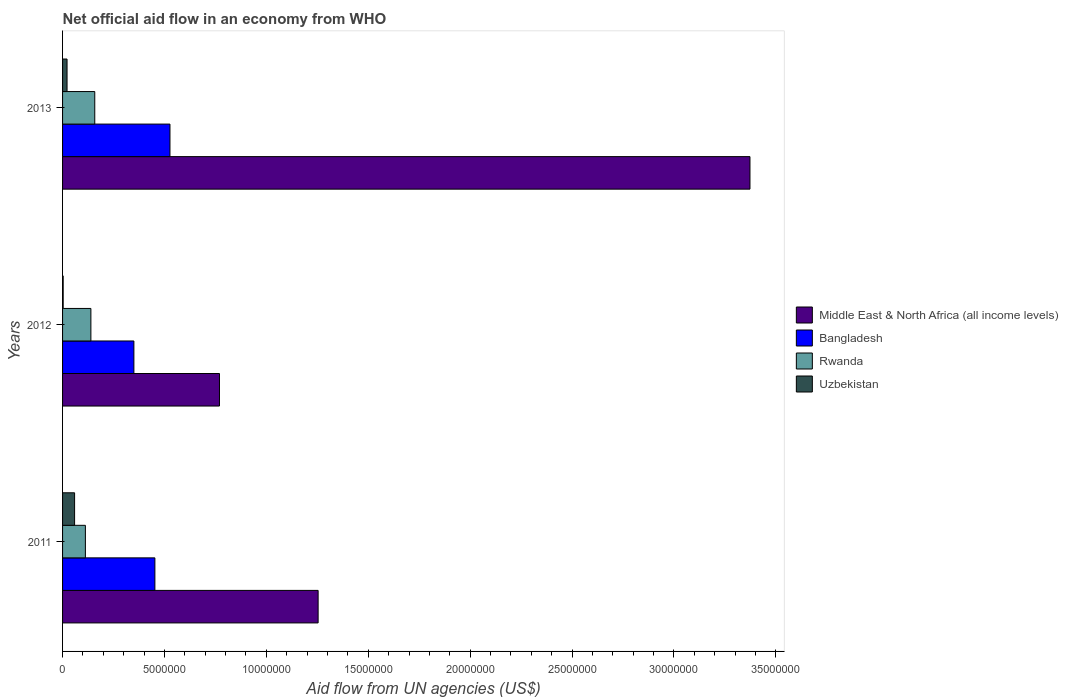How many groups of bars are there?
Provide a succinct answer. 3. Are the number of bars per tick equal to the number of legend labels?
Offer a terse response. Yes. How many bars are there on the 1st tick from the bottom?
Provide a short and direct response. 4. What is the label of the 1st group of bars from the top?
Offer a terse response. 2013. What is the net official aid flow in Rwanda in 2013?
Offer a very short reply. 1.58e+06. Across all years, what is the maximum net official aid flow in Middle East & North Africa (all income levels)?
Keep it short and to the point. 3.37e+07. Across all years, what is the minimum net official aid flow in Rwanda?
Offer a terse response. 1.12e+06. What is the total net official aid flow in Middle East & North Africa (all income levels) in the graph?
Provide a succinct answer. 5.40e+07. What is the difference between the net official aid flow in Bangladesh in 2011 and the net official aid flow in Uzbekistan in 2013?
Your response must be concise. 4.31e+06. What is the average net official aid flow in Bangladesh per year?
Keep it short and to the point. 4.43e+06. In the year 2012, what is the difference between the net official aid flow in Uzbekistan and net official aid flow in Bangladesh?
Offer a very short reply. -3.47e+06. What is the ratio of the net official aid flow in Uzbekistan in 2012 to that in 2013?
Keep it short and to the point. 0.14. Is the net official aid flow in Rwanda in 2011 less than that in 2013?
Your answer should be compact. Yes. What is the difference between the highest and the lowest net official aid flow in Rwanda?
Offer a terse response. 4.60e+05. What does the 1st bar from the top in 2013 represents?
Keep it short and to the point. Uzbekistan. What does the 3rd bar from the bottom in 2013 represents?
Your answer should be very brief. Rwanda. Does the graph contain any zero values?
Offer a terse response. No. What is the title of the graph?
Ensure brevity in your answer.  Net official aid flow in an economy from WHO. What is the label or title of the X-axis?
Provide a short and direct response. Aid flow from UN agencies (US$). What is the label or title of the Y-axis?
Your answer should be compact. Years. What is the Aid flow from UN agencies (US$) in Middle East & North Africa (all income levels) in 2011?
Provide a succinct answer. 1.25e+07. What is the Aid flow from UN agencies (US$) of Bangladesh in 2011?
Your answer should be very brief. 4.53e+06. What is the Aid flow from UN agencies (US$) in Rwanda in 2011?
Your answer should be compact. 1.12e+06. What is the Aid flow from UN agencies (US$) in Uzbekistan in 2011?
Your response must be concise. 5.90e+05. What is the Aid flow from UN agencies (US$) of Middle East & North Africa (all income levels) in 2012?
Your response must be concise. 7.70e+06. What is the Aid flow from UN agencies (US$) of Bangladesh in 2012?
Ensure brevity in your answer.  3.50e+06. What is the Aid flow from UN agencies (US$) in Rwanda in 2012?
Offer a terse response. 1.39e+06. What is the Aid flow from UN agencies (US$) in Middle East & North Africa (all income levels) in 2013?
Provide a succinct answer. 3.37e+07. What is the Aid flow from UN agencies (US$) of Bangladesh in 2013?
Offer a terse response. 5.27e+06. What is the Aid flow from UN agencies (US$) in Rwanda in 2013?
Your answer should be very brief. 1.58e+06. Across all years, what is the maximum Aid flow from UN agencies (US$) in Middle East & North Africa (all income levels)?
Provide a succinct answer. 3.37e+07. Across all years, what is the maximum Aid flow from UN agencies (US$) in Bangladesh?
Keep it short and to the point. 5.27e+06. Across all years, what is the maximum Aid flow from UN agencies (US$) of Rwanda?
Make the answer very short. 1.58e+06. Across all years, what is the maximum Aid flow from UN agencies (US$) in Uzbekistan?
Ensure brevity in your answer.  5.90e+05. Across all years, what is the minimum Aid flow from UN agencies (US$) in Middle East & North Africa (all income levels)?
Offer a terse response. 7.70e+06. Across all years, what is the minimum Aid flow from UN agencies (US$) of Bangladesh?
Make the answer very short. 3.50e+06. Across all years, what is the minimum Aid flow from UN agencies (US$) in Rwanda?
Offer a terse response. 1.12e+06. What is the total Aid flow from UN agencies (US$) of Middle East & North Africa (all income levels) in the graph?
Provide a short and direct response. 5.40e+07. What is the total Aid flow from UN agencies (US$) in Bangladesh in the graph?
Your answer should be compact. 1.33e+07. What is the total Aid flow from UN agencies (US$) of Rwanda in the graph?
Offer a very short reply. 4.09e+06. What is the total Aid flow from UN agencies (US$) in Uzbekistan in the graph?
Your response must be concise. 8.40e+05. What is the difference between the Aid flow from UN agencies (US$) of Middle East & North Africa (all income levels) in 2011 and that in 2012?
Your answer should be compact. 4.84e+06. What is the difference between the Aid flow from UN agencies (US$) of Bangladesh in 2011 and that in 2012?
Give a very brief answer. 1.03e+06. What is the difference between the Aid flow from UN agencies (US$) of Uzbekistan in 2011 and that in 2012?
Keep it short and to the point. 5.60e+05. What is the difference between the Aid flow from UN agencies (US$) of Middle East & North Africa (all income levels) in 2011 and that in 2013?
Your answer should be very brief. -2.12e+07. What is the difference between the Aid flow from UN agencies (US$) in Bangladesh in 2011 and that in 2013?
Give a very brief answer. -7.40e+05. What is the difference between the Aid flow from UN agencies (US$) in Rwanda in 2011 and that in 2013?
Give a very brief answer. -4.60e+05. What is the difference between the Aid flow from UN agencies (US$) of Middle East & North Africa (all income levels) in 2012 and that in 2013?
Your response must be concise. -2.60e+07. What is the difference between the Aid flow from UN agencies (US$) in Bangladesh in 2012 and that in 2013?
Your answer should be compact. -1.77e+06. What is the difference between the Aid flow from UN agencies (US$) of Uzbekistan in 2012 and that in 2013?
Provide a succinct answer. -1.90e+05. What is the difference between the Aid flow from UN agencies (US$) of Middle East & North Africa (all income levels) in 2011 and the Aid flow from UN agencies (US$) of Bangladesh in 2012?
Offer a terse response. 9.04e+06. What is the difference between the Aid flow from UN agencies (US$) in Middle East & North Africa (all income levels) in 2011 and the Aid flow from UN agencies (US$) in Rwanda in 2012?
Your response must be concise. 1.12e+07. What is the difference between the Aid flow from UN agencies (US$) in Middle East & North Africa (all income levels) in 2011 and the Aid flow from UN agencies (US$) in Uzbekistan in 2012?
Make the answer very short. 1.25e+07. What is the difference between the Aid flow from UN agencies (US$) in Bangladesh in 2011 and the Aid flow from UN agencies (US$) in Rwanda in 2012?
Your answer should be very brief. 3.14e+06. What is the difference between the Aid flow from UN agencies (US$) in Bangladesh in 2011 and the Aid flow from UN agencies (US$) in Uzbekistan in 2012?
Provide a succinct answer. 4.50e+06. What is the difference between the Aid flow from UN agencies (US$) of Rwanda in 2011 and the Aid flow from UN agencies (US$) of Uzbekistan in 2012?
Your answer should be very brief. 1.09e+06. What is the difference between the Aid flow from UN agencies (US$) in Middle East & North Africa (all income levels) in 2011 and the Aid flow from UN agencies (US$) in Bangladesh in 2013?
Make the answer very short. 7.27e+06. What is the difference between the Aid flow from UN agencies (US$) of Middle East & North Africa (all income levels) in 2011 and the Aid flow from UN agencies (US$) of Rwanda in 2013?
Make the answer very short. 1.10e+07. What is the difference between the Aid flow from UN agencies (US$) in Middle East & North Africa (all income levels) in 2011 and the Aid flow from UN agencies (US$) in Uzbekistan in 2013?
Make the answer very short. 1.23e+07. What is the difference between the Aid flow from UN agencies (US$) in Bangladesh in 2011 and the Aid flow from UN agencies (US$) in Rwanda in 2013?
Ensure brevity in your answer.  2.95e+06. What is the difference between the Aid flow from UN agencies (US$) of Bangladesh in 2011 and the Aid flow from UN agencies (US$) of Uzbekistan in 2013?
Offer a very short reply. 4.31e+06. What is the difference between the Aid flow from UN agencies (US$) of Rwanda in 2011 and the Aid flow from UN agencies (US$) of Uzbekistan in 2013?
Your answer should be very brief. 9.00e+05. What is the difference between the Aid flow from UN agencies (US$) in Middle East & North Africa (all income levels) in 2012 and the Aid flow from UN agencies (US$) in Bangladesh in 2013?
Offer a very short reply. 2.43e+06. What is the difference between the Aid flow from UN agencies (US$) of Middle East & North Africa (all income levels) in 2012 and the Aid flow from UN agencies (US$) of Rwanda in 2013?
Keep it short and to the point. 6.12e+06. What is the difference between the Aid flow from UN agencies (US$) in Middle East & North Africa (all income levels) in 2012 and the Aid flow from UN agencies (US$) in Uzbekistan in 2013?
Give a very brief answer. 7.48e+06. What is the difference between the Aid flow from UN agencies (US$) of Bangladesh in 2012 and the Aid flow from UN agencies (US$) of Rwanda in 2013?
Provide a succinct answer. 1.92e+06. What is the difference between the Aid flow from UN agencies (US$) in Bangladesh in 2012 and the Aid flow from UN agencies (US$) in Uzbekistan in 2013?
Your response must be concise. 3.28e+06. What is the difference between the Aid flow from UN agencies (US$) of Rwanda in 2012 and the Aid flow from UN agencies (US$) of Uzbekistan in 2013?
Offer a terse response. 1.17e+06. What is the average Aid flow from UN agencies (US$) of Middle East & North Africa (all income levels) per year?
Keep it short and to the point. 1.80e+07. What is the average Aid flow from UN agencies (US$) in Bangladesh per year?
Your response must be concise. 4.43e+06. What is the average Aid flow from UN agencies (US$) in Rwanda per year?
Provide a short and direct response. 1.36e+06. What is the average Aid flow from UN agencies (US$) of Uzbekistan per year?
Your response must be concise. 2.80e+05. In the year 2011, what is the difference between the Aid flow from UN agencies (US$) of Middle East & North Africa (all income levels) and Aid flow from UN agencies (US$) of Bangladesh?
Your answer should be compact. 8.01e+06. In the year 2011, what is the difference between the Aid flow from UN agencies (US$) of Middle East & North Africa (all income levels) and Aid flow from UN agencies (US$) of Rwanda?
Offer a very short reply. 1.14e+07. In the year 2011, what is the difference between the Aid flow from UN agencies (US$) in Middle East & North Africa (all income levels) and Aid flow from UN agencies (US$) in Uzbekistan?
Keep it short and to the point. 1.20e+07. In the year 2011, what is the difference between the Aid flow from UN agencies (US$) of Bangladesh and Aid flow from UN agencies (US$) of Rwanda?
Make the answer very short. 3.41e+06. In the year 2011, what is the difference between the Aid flow from UN agencies (US$) in Bangladesh and Aid flow from UN agencies (US$) in Uzbekistan?
Your response must be concise. 3.94e+06. In the year 2011, what is the difference between the Aid flow from UN agencies (US$) of Rwanda and Aid flow from UN agencies (US$) of Uzbekistan?
Offer a terse response. 5.30e+05. In the year 2012, what is the difference between the Aid flow from UN agencies (US$) of Middle East & North Africa (all income levels) and Aid flow from UN agencies (US$) of Bangladesh?
Your answer should be very brief. 4.20e+06. In the year 2012, what is the difference between the Aid flow from UN agencies (US$) of Middle East & North Africa (all income levels) and Aid flow from UN agencies (US$) of Rwanda?
Provide a short and direct response. 6.31e+06. In the year 2012, what is the difference between the Aid flow from UN agencies (US$) in Middle East & North Africa (all income levels) and Aid flow from UN agencies (US$) in Uzbekistan?
Provide a short and direct response. 7.67e+06. In the year 2012, what is the difference between the Aid flow from UN agencies (US$) in Bangladesh and Aid flow from UN agencies (US$) in Rwanda?
Provide a short and direct response. 2.11e+06. In the year 2012, what is the difference between the Aid flow from UN agencies (US$) in Bangladesh and Aid flow from UN agencies (US$) in Uzbekistan?
Your answer should be compact. 3.47e+06. In the year 2012, what is the difference between the Aid flow from UN agencies (US$) in Rwanda and Aid flow from UN agencies (US$) in Uzbekistan?
Keep it short and to the point. 1.36e+06. In the year 2013, what is the difference between the Aid flow from UN agencies (US$) in Middle East & North Africa (all income levels) and Aid flow from UN agencies (US$) in Bangladesh?
Offer a very short reply. 2.85e+07. In the year 2013, what is the difference between the Aid flow from UN agencies (US$) in Middle East & North Africa (all income levels) and Aid flow from UN agencies (US$) in Rwanda?
Offer a terse response. 3.22e+07. In the year 2013, what is the difference between the Aid flow from UN agencies (US$) of Middle East & North Africa (all income levels) and Aid flow from UN agencies (US$) of Uzbekistan?
Make the answer very short. 3.35e+07. In the year 2013, what is the difference between the Aid flow from UN agencies (US$) of Bangladesh and Aid flow from UN agencies (US$) of Rwanda?
Provide a short and direct response. 3.69e+06. In the year 2013, what is the difference between the Aid flow from UN agencies (US$) in Bangladesh and Aid flow from UN agencies (US$) in Uzbekistan?
Offer a very short reply. 5.05e+06. In the year 2013, what is the difference between the Aid flow from UN agencies (US$) of Rwanda and Aid flow from UN agencies (US$) of Uzbekistan?
Your answer should be very brief. 1.36e+06. What is the ratio of the Aid flow from UN agencies (US$) in Middle East & North Africa (all income levels) in 2011 to that in 2012?
Offer a very short reply. 1.63. What is the ratio of the Aid flow from UN agencies (US$) of Bangladesh in 2011 to that in 2012?
Your answer should be very brief. 1.29. What is the ratio of the Aid flow from UN agencies (US$) in Rwanda in 2011 to that in 2012?
Make the answer very short. 0.81. What is the ratio of the Aid flow from UN agencies (US$) of Uzbekistan in 2011 to that in 2012?
Keep it short and to the point. 19.67. What is the ratio of the Aid flow from UN agencies (US$) of Middle East & North Africa (all income levels) in 2011 to that in 2013?
Ensure brevity in your answer.  0.37. What is the ratio of the Aid flow from UN agencies (US$) of Bangladesh in 2011 to that in 2013?
Provide a succinct answer. 0.86. What is the ratio of the Aid flow from UN agencies (US$) of Rwanda in 2011 to that in 2013?
Give a very brief answer. 0.71. What is the ratio of the Aid flow from UN agencies (US$) in Uzbekistan in 2011 to that in 2013?
Keep it short and to the point. 2.68. What is the ratio of the Aid flow from UN agencies (US$) of Middle East & North Africa (all income levels) in 2012 to that in 2013?
Your answer should be very brief. 0.23. What is the ratio of the Aid flow from UN agencies (US$) in Bangladesh in 2012 to that in 2013?
Offer a very short reply. 0.66. What is the ratio of the Aid flow from UN agencies (US$) in Rwanda in 2012 to that in 2013?
Give a very brief answer. 0.88. What is the ratio of the Aid flow from UN agencies (US$) in Uzbekistan in 2012 to that in 2013?
Make the answer very short. 0.14. What is the difference between the highest and the second highest Aid flow from UN agencies (US$) of Middle East & North Africa (all income levels)?
Offer a terse response. 2.12e+07. What is the difference between the highest and the second highest Aid flow from UN agencies (US$) in Bangladesh?
Make the answer very short. 7.40e+05. What is the difference between the highest and the second highest Aid flow from UN agencies (US$) in Uzbekistan?
Your answer should be compact. 3.70e+05. What is the difference between the highest and the lowest Aid flow from UN agencies (US$) of Middle East & North Africa (all income levels)?
Make the answer very short. 2.60e+07. What is the difference between the highest and the lowest Aid flow from UN agencies (US$) of Bangladesh?
Your answer should be compact. 1.77e+06. What is the difference between the highest and the lowest Aid flow from UN agencies (US$) of Rwanda?
Keep it short and to the point. 4.60e+05. What is the difference between the highest and the lowest Aid flow from UN agencies (US$) in Uzbekistan?
Make the answer very short. 5.60e+05. 